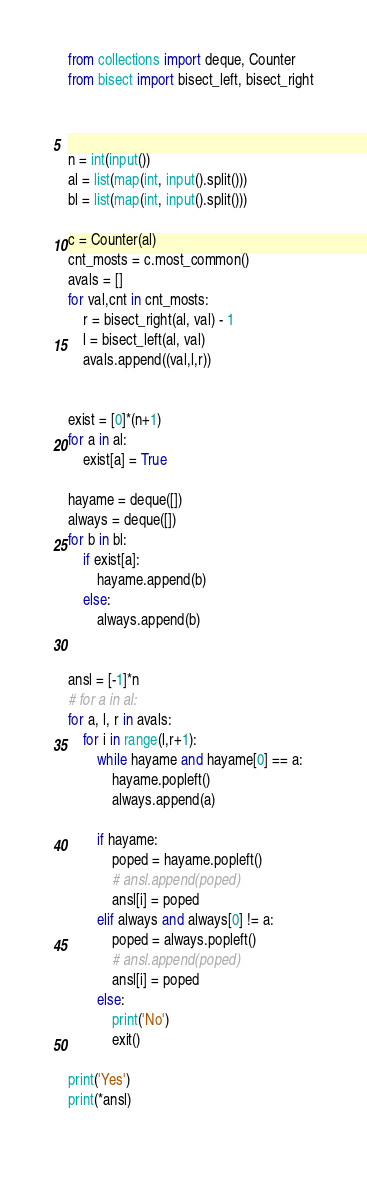<code> <loc_0><loc_0><loc_500><loc_500><_Python_>from collections import deque, Counter
from bisect import bisect_left, bisect_right



n = int(input())
al = list(map(int, input().split()))
bl = list(map(int, input().split()))

c = Counter(al)
cnt_mosts = c.most_common()
avals = []
for val,cnt in cnt_mosts:
    r = bisect_right(al, val) - 1
    l = bisect_left(al, val)
    avals.append((val,l,r))


exist = [0]*(n+1)
for a in al:
    exist[a] = True

hayame = deque([])
always = deque([])
for b in bl:
    if exist[a]:
        hayame.append(b)
    else:
        always.append(b)


ansl = [-1]*n
# for a in al:
for a, l, r in avals:
    for i in range(l,r+1):
        while hayame and hayame[0] == a:
            hayame.popleft()
            always.append(a)

        if hayame:
            poped = hayame.popleft()
            # ansl.append(poped)
            ansl[i] = poped
        elif always and always[0] != a:
            poped = always.popleft()
            # ansl.append(poped)
            ansl[i] = poped
        else:
            print('No')
            exit()

print('Yes')
print(*ansl)
        </code> 